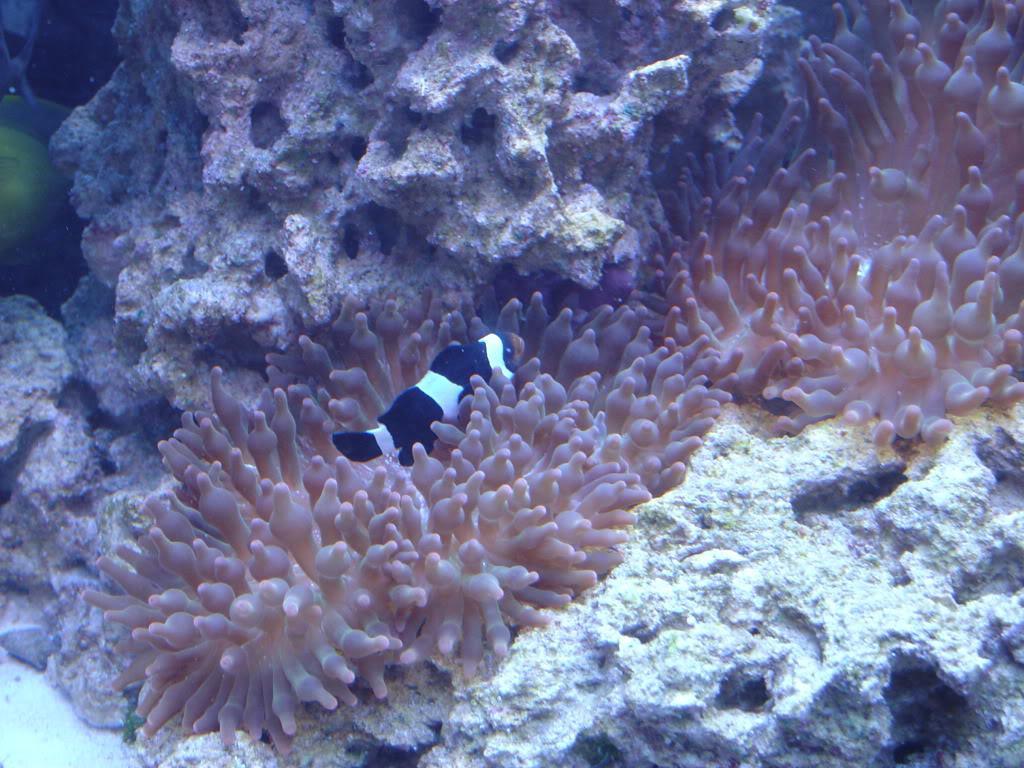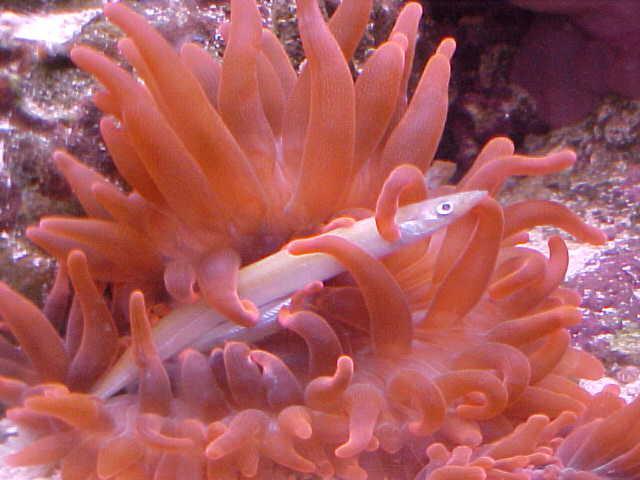The first image is the image on the left, the second image is the image on the right. Examine the images to the left and right. Is the description "In one image, there is a black and white striped fish visible near a sea anemone" accurate? Answer yes or no. Yes. The first image is the image on the left, the second image is the image on the right. Evaluate the accuracy of this statement regarding the images: "The right image shows a pinkish anemone with a fish in its tendrils.". Is it true? Answer yes or no. Yes. 